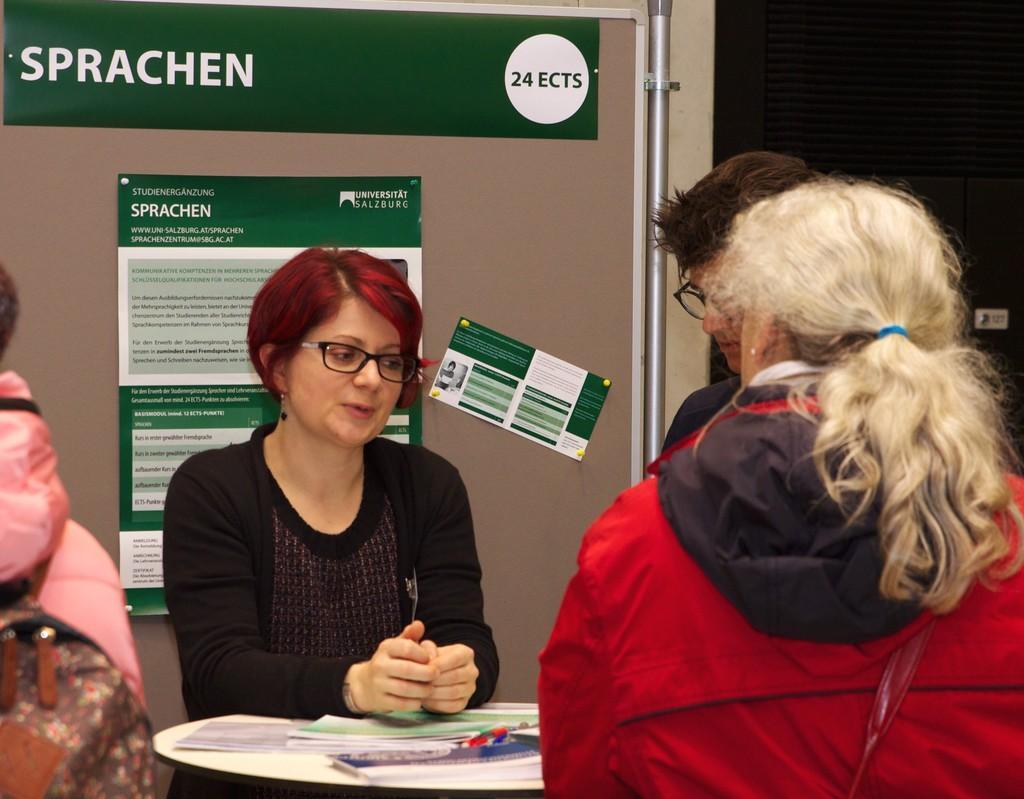In one or two sentences, can you explain what this image depicts? In this image we can see a few people, there is a table, on that there are papers, and a pen, there are posters on the board, there are text on the posters, also we can see the wall. 